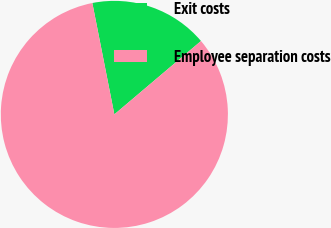Convert chart to OTSL. <chart><loc_0><loc_0><loc_500><loc_500><pie_chart><fcel>Exit costs<fcel>Employee separation costs<nl><fcel>16.92%<fcel>83.08%<nl></chart> 